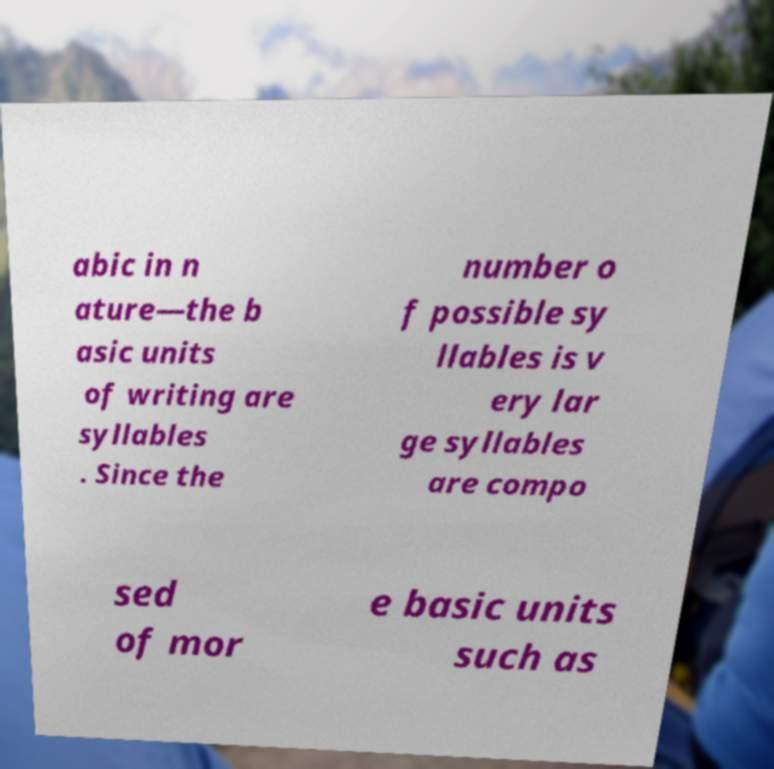Please read and relay the text visible in this image. What does it say? abic in n ature—the b asic units of writing are syllables . Since the number o f possible sy llables is v ery lar ge syllables are compo sed of mor e basic units such as 